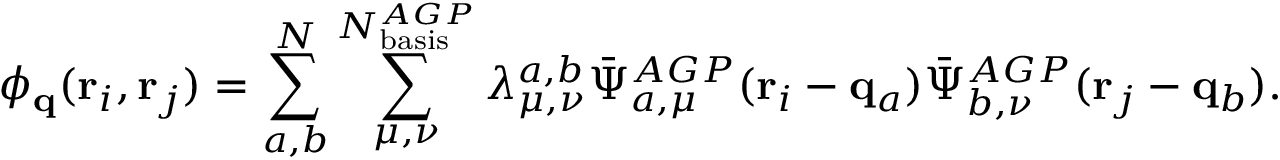<formula> <loc_0><loc_0><loc_500><loc_500>\phi _ { q } ( r _ { i } , r _ { j } ) = \sum _ { a , b } ^ { N } \sum _ { \mu , \nu } ^ { N _ { b a s i s } ^ { A G P } } \lambda _ { \mu , \nu } ^ { a , b } \bar { \Psi } _ { a , \mu } ^ { A G P } ( r _ { i } - q _ { a } ) \bar { \Psi } _ { b , \nu } ^ { A G P } ( r _ { j } - q _ { b } ) .</formula> 